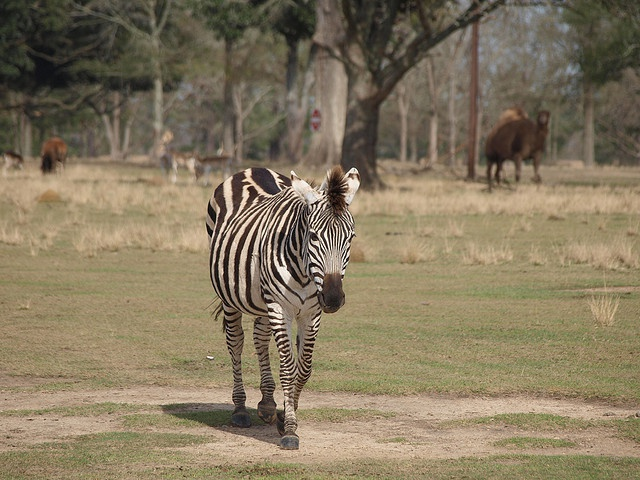Describe the objects in this image and their specific colors. I can see zebra in black, gray, and darkgray tones and stop sign in black, brown, and gray tones in this image. 